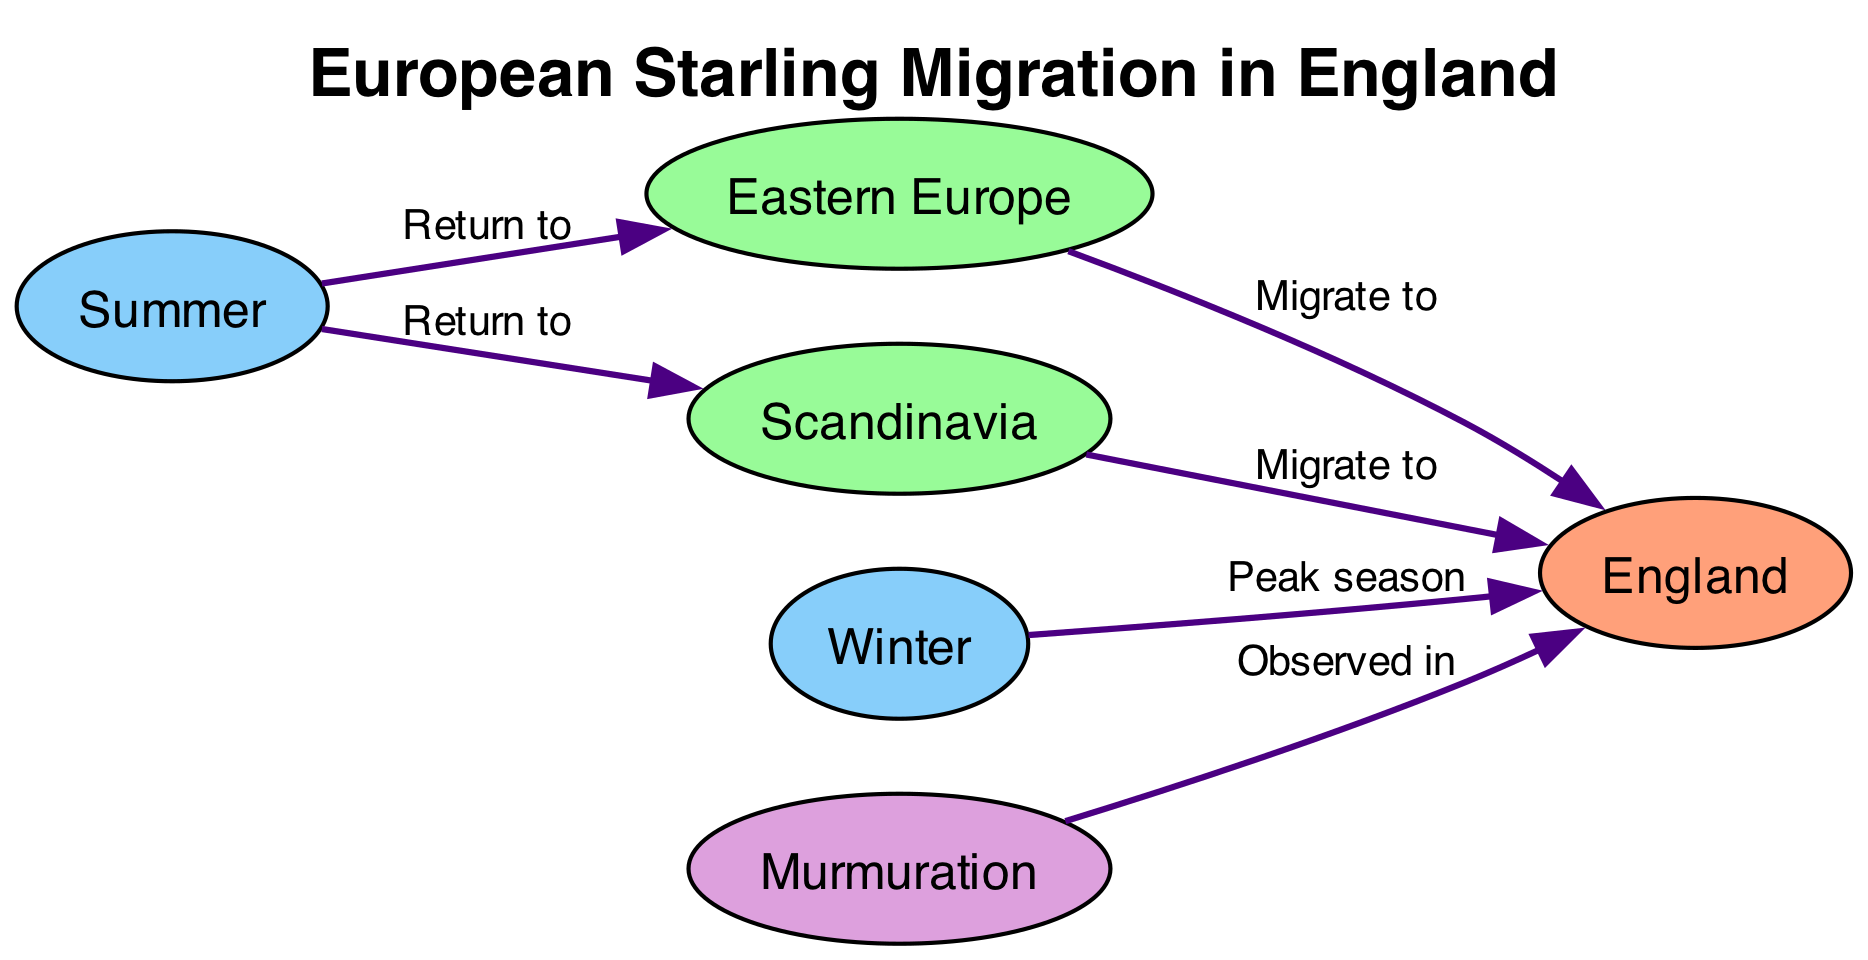What is the title of the diagram? The title of the diagram is provided in the data structure under the key "title". Thus, we simply use the value associated with this key: "European Starling Migration in England."
Answer: European Starling Migration in England How many nodes are in the diagram? The nodes are listed in the "nodes" section of the data. There are six entries under this section, indicating there are six nodes in total.
Answer: 6 What type of migration do starlings exhibit from Eastern Europe to England? The diagram indicates that starlings "Migrate to" England from Eastern Europe. The relationship label between the two nodes confirms this is a migration.
Answer: Migrate to Which season is labeled as the peak season for starlings in England? The edge from "Winter" to "England" is labeled as "Peak season," indicating that winter is the time when starlings are most commonly observed in England.
Answer: Winter Where do starlings return to during the summer? The diagram explicitly shows an edge from "Summer" to "Eastern Europe" and from "Summer" to "Scandinavia," meaning that during summer, starlings return to these regions.
Answer: Eastern Europe, Scandinavia How many relationships indicate migration to England from other regions? To answer this, we review the edges that originate from the regions and point to England: there are two edges (one from Eastern Europe and one from Scandinavia), confirming the starlings migrate from two places to England.
Answer: 2 In which season are starlings observed in England? The "Behavior" node labeled "Murmuration" has an edge pointing to "England," indicating that starlings exhibiting this behavior are observed in England. The combination of nodes and edges confirms this observation.
Answer: Observed in What behavior is associated with starlings seen in England? The edge from the node "Murmuration" to "England" specifies that this behavior is the one associated with starlings present in England. This indicates that the starlings are noted for their murmurations when observed there.
Answer: Murmuration 